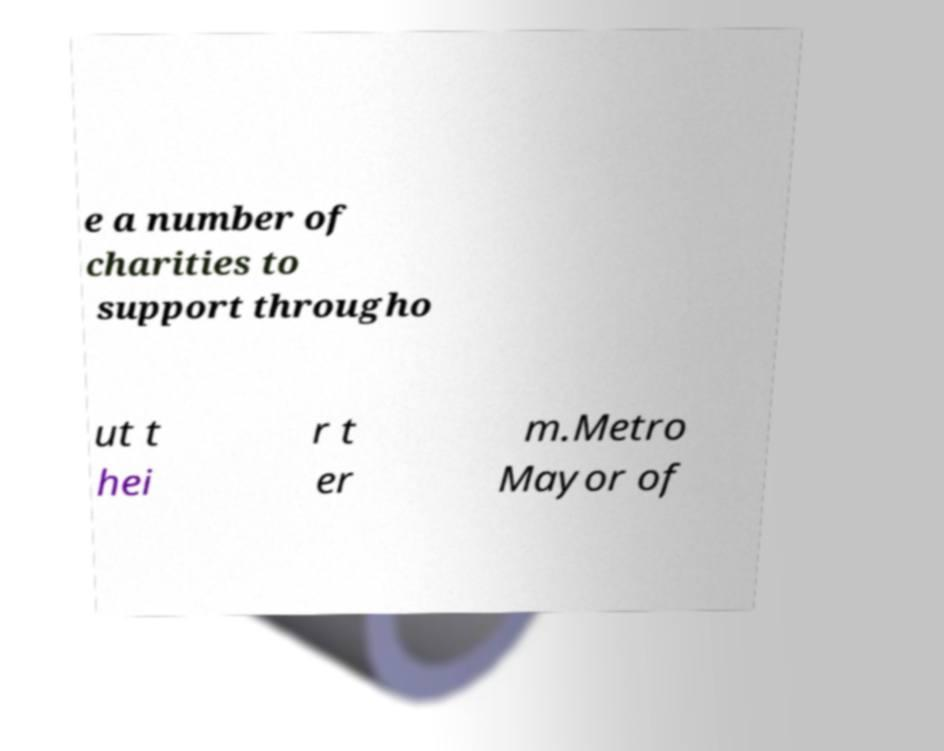Please identify and transcribe the text found in this image. e a number of charities to support througho ut t hei r t er m.Metro Mayor of 